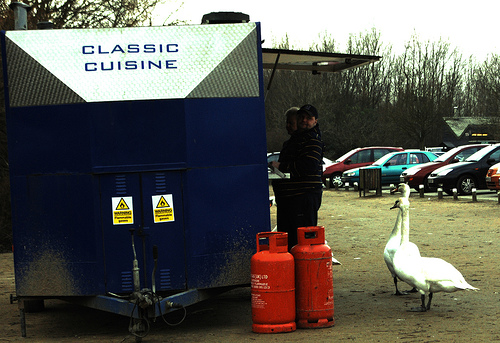<image>
Is there a bird to the right of the person? Yes. From this viewpoint, the bird is positioned to the right side relative to the person. 